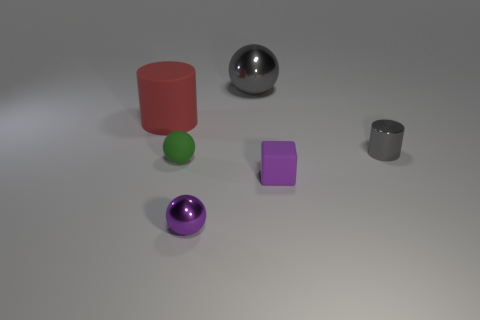Is there anything else that is made of the same material as the gray sphere?
Provide a short and direct response. Yes. There is a metallic object that is the same color as the tiny rubber cube; what shape is it?
Your response must be concise. Sphere. How many shiny objects have the same shape as the green rubber thing?
Keep it short and to the point. 2. There is a cylinder that is left of the green matte thing; is it the same size as the metallic object on the right side of the large metallic thing?
Offer a terse response. No. There is a tiny purple thing that is right of the big gray metal object; what shape is it?
Provide a short and direct response. Cube. What is the material of the large sphere to the left of the rubber block that is right of the small green thing?
Provide a short and direct response. Metal. Are there any rubber cubes that have the same color as the small metallic cylinder?
Provide a short and direct response. No. There is a gray metal ball; is its size the same as the cylinder that is left of the purple matte thing?
Make the answer very short. Yes. How many small purple cubes are behind the gray object in front of the object that is behind the matte cylinder?
Provide a succinct answer. 0. What number of spheres are to the right of the green matte sphere?
Give a very brief answer. 2. 